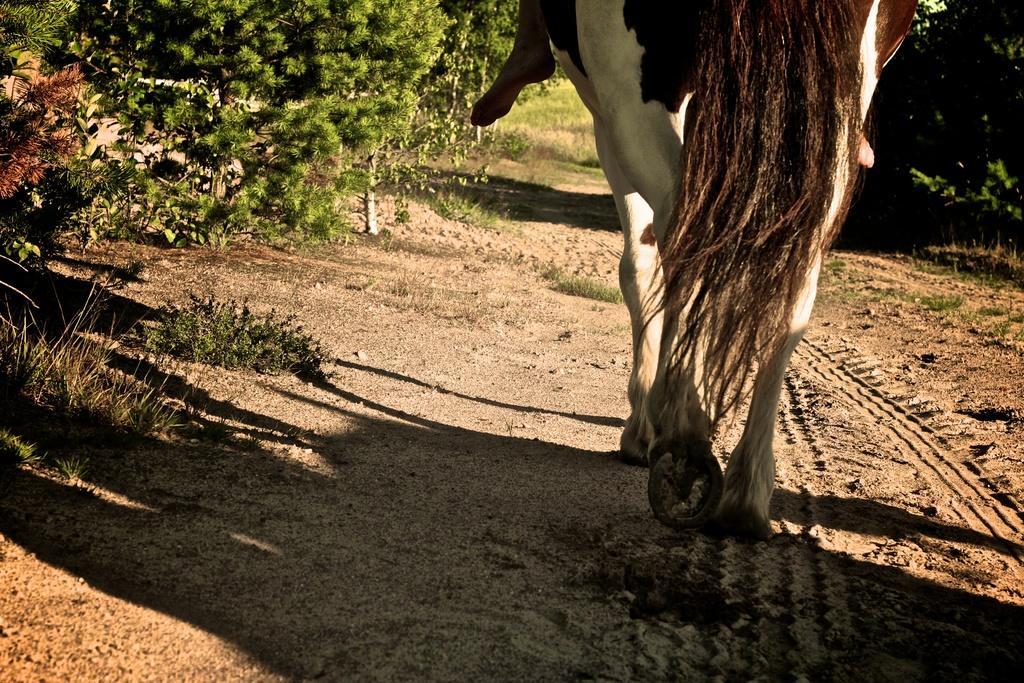Could you give a brief overview of what you see in this image? In this image I see a horse and I see a person's leg over here and I see the soil and I see the grass and the plants. 